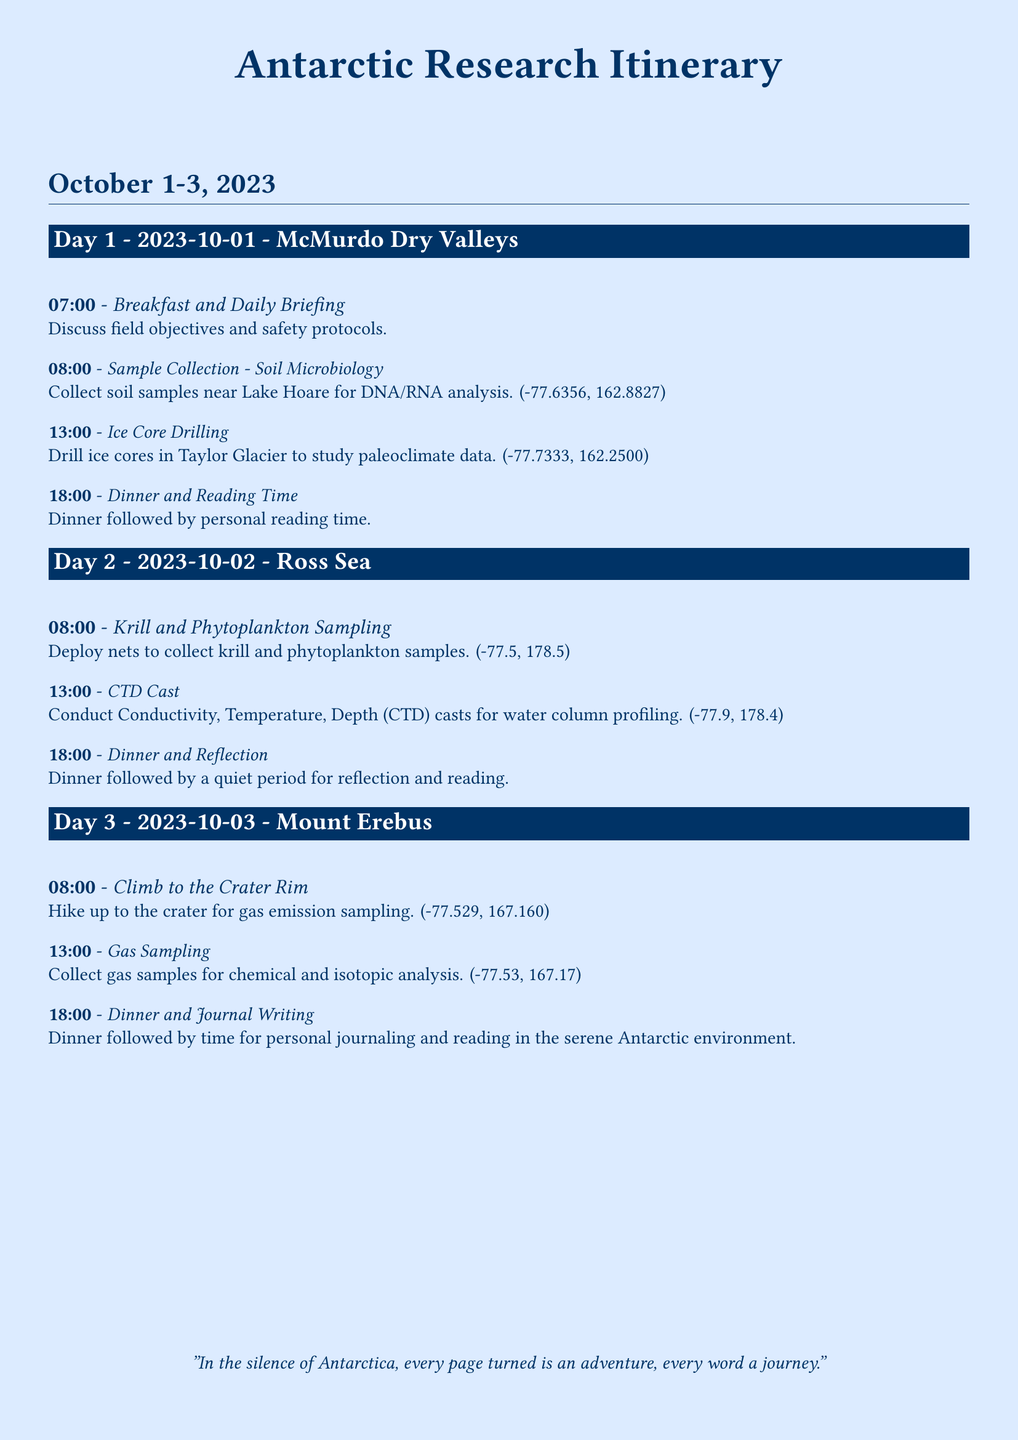What is the location for soil sample collection? The document specifies that soil samples are collected near Lake Hoare at coordinates (-77.6356, 162.8827).
Answer: Lake Hoare What time does the ice core drilling start on Day 1? The itinerary indicates that ice core drilling starts at 13:00 on the first day.
Answer: 13:00 What type of sampling is conducted at the Ross Sea on Day 2? The document mentions krill and phytoplankton sampling as the primary activity on the second day.
Answer: Krill and Phytoplankton Sampling How many activities are scheduled on Day 2? By reviewing the activities listed for Day 2, we see there are three specific activities planned.
Answer: 3 What is the last activity of Day 3? The itinerary clearly states that the last activity on Day 3 is dinner followed by journaling and reading.
Answer: Dinner and Journal Writing Which glacier is mentioned for ice core drilling? The document states that ice core drilling is to be done at Taylor Glacier.
Answer: Taylor Glacier What is the primary focus of gas sampling on Day 3? The activity highlights that gas samples are collected for chemical and isotopic analysis.
Answer: Chemical and Isotopic Analysis What is the primary purpose of the daily briefing? The daily briefing is focused on discussing field objectives and safety protocols.
Answer: Field objectives and safety protocols 